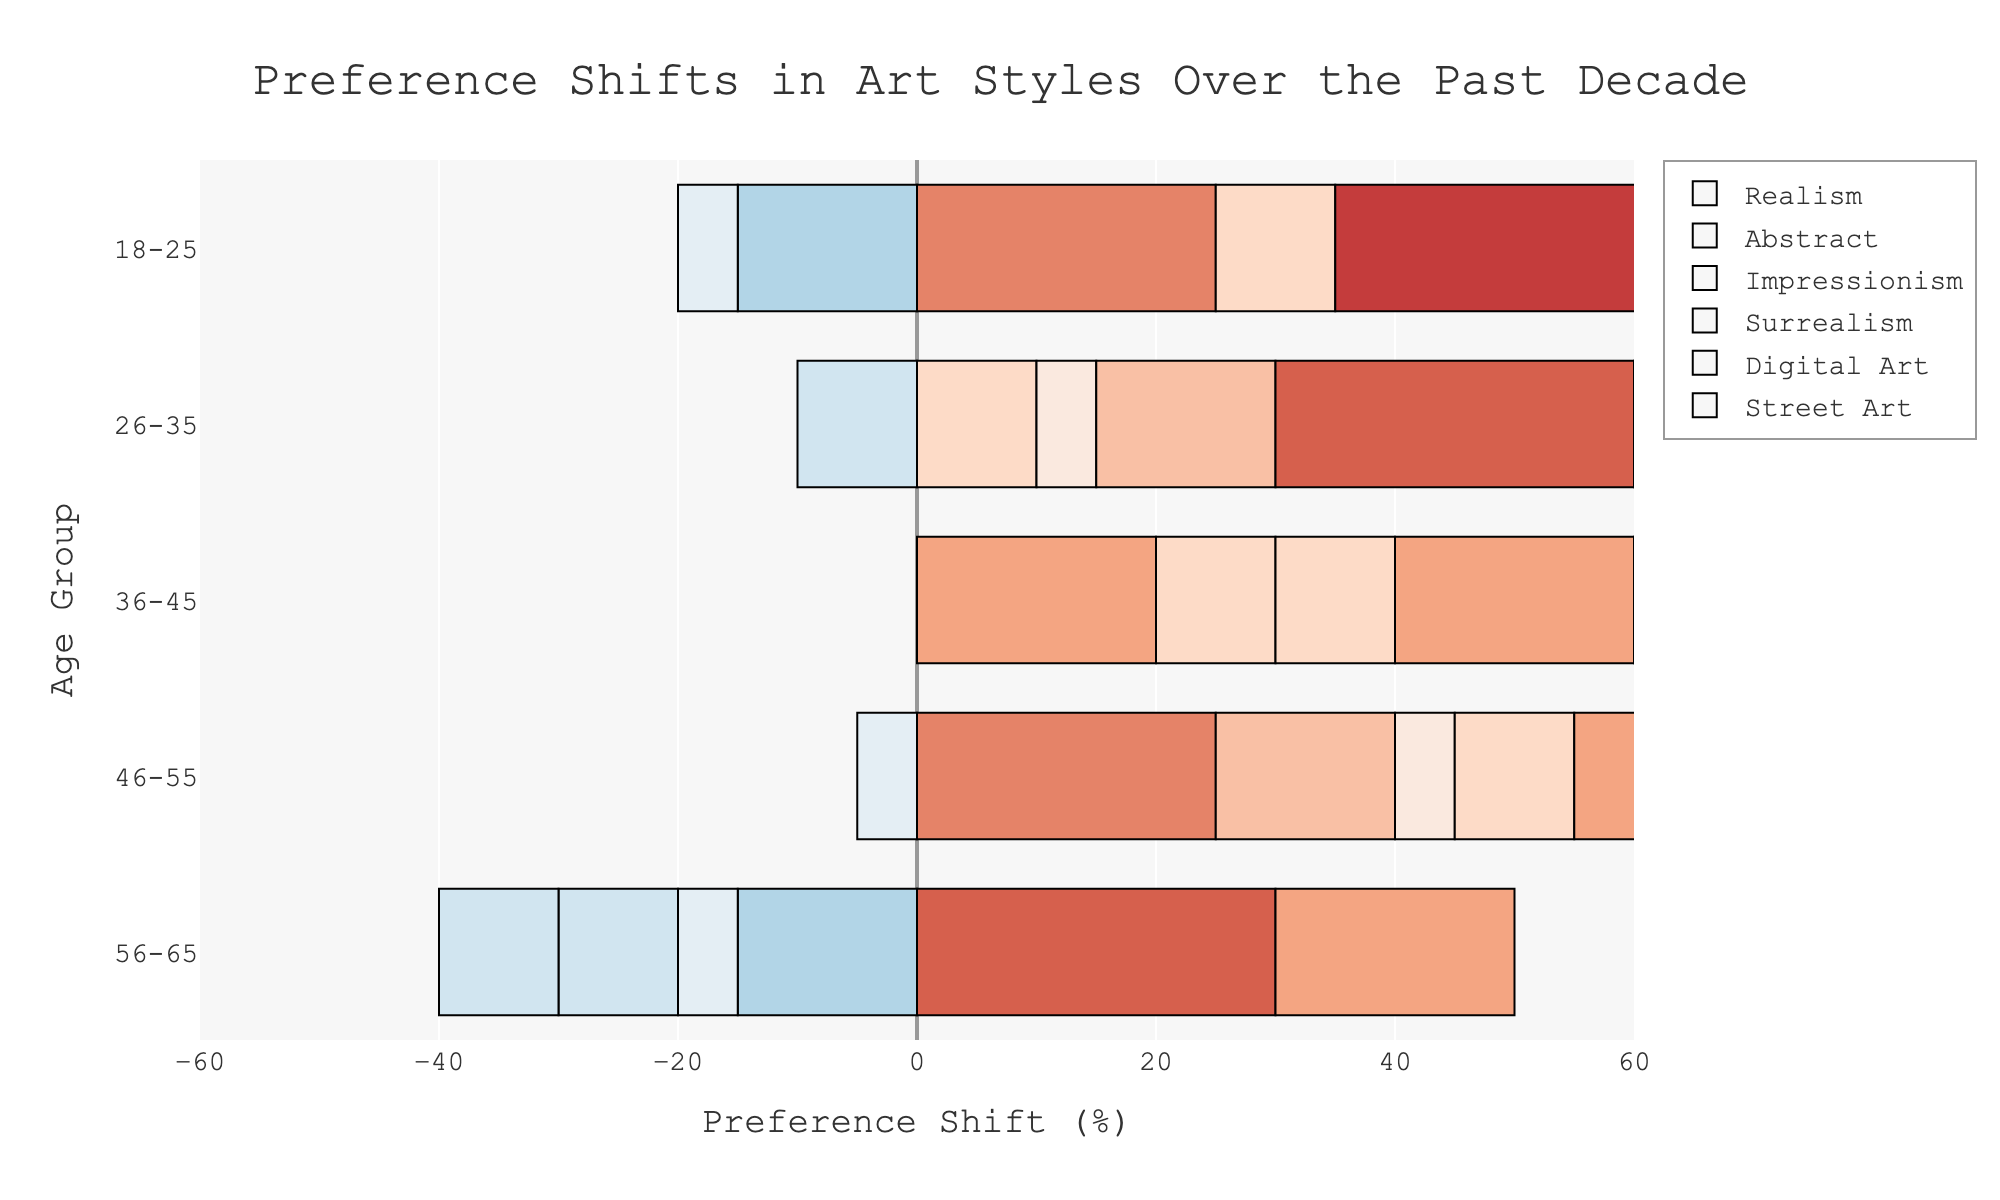What age group shows the highest positive preference shift for Realism? Look at the bar lengths and colors representing Realism for each age group. The longest positive bar is for 56-65, showing the highest shift.
Answer: 56-65 Which art style has the largest positive preference shift for the 18-25 age group? Examine the lengths and colors of the bars for the 18-25 age group. The largest positive shift is for Street Art.
Answer: Street Art How does the preference shift for Abstract Art compare between the 26-35 and 56-65 age groups? Compare the bars for Abstract Art in the 26-35 (-10) and 56-65 (-15) age groups. Both are negative, but 56-65 is more negative.
Answer: 56-65 is more negative What is the combined preference shift for Surrealism and Digital Art in the 36-45 age group? Add the values of Surrealism (10) and Digital Art (20) for the 36-45 age group. 10 + 20 = 30
Answer: 30 Which age group shows a negative shift for Impressionism, and by how much? Identify the age group with a negative bar for Impressionism, which is 18-25 with a shift of -5.
Answer: 18-25, -5 Is there any age group with no preference shift for any art style? Check all bars across age groups; all groups show shifts. Hence, no age group has zero shift for any art style.
Answer: No How does the preference shift for Digital Art vary across age groups? Observe the lengths and colors of the bars for Digital Art among different age groups: 18-25 (35), 26-35 (30), 36-45 (20), 46-55 (10), 56-65 (-10).
Answer: Decreases with age Which art style shows the highest variability in preference shifts across different age groups? Compare the range of shifts for each art style across age groups. Street Art has the widest range: from 50 (18-25) to 20 (56-65).
Answer: Street Art What color marker denotes the highest negative preference shift in Abstract Art? Examine the color for the Art style with the highest negative value in Abstract Art. The most negative shift (-15) is in the 56-65 age group, marked with a deep blue color.
Answer: Deep blue For the age group 46-55, which art style has the lowest positive preference shift? Compare the positive bars for the 46-55 age group. Surrealism has the shortest positive bar with a shift of 5.
Answer: Surrealism 